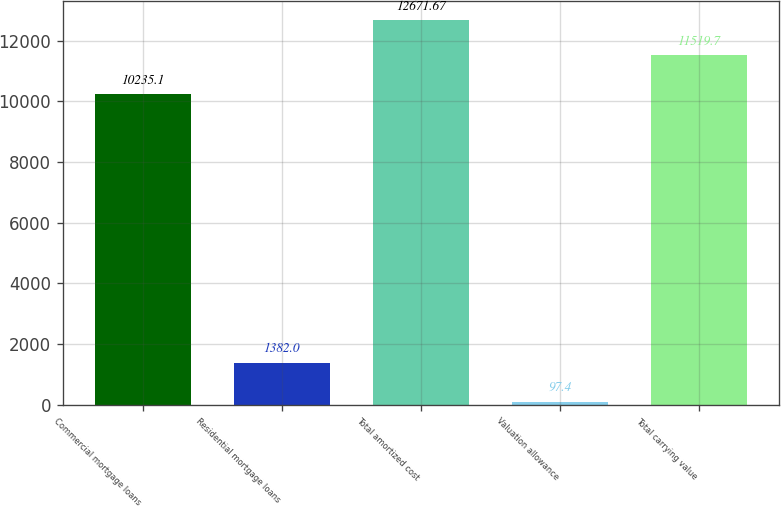Convert chart. <chart><loc_0><loc_0><loc_500><loc_500><bar_chart><fcel>Commercial mortgage loans<fcel>Residential mortgage loans<fcel>Total amortized cost<fcel>Valuation allowance<fcel>Total carrying value<nl><fcel>10235.1<fcel>1382<fcel>12671.7<fcel>97.4<fcel>11519.7<nl></chart> 